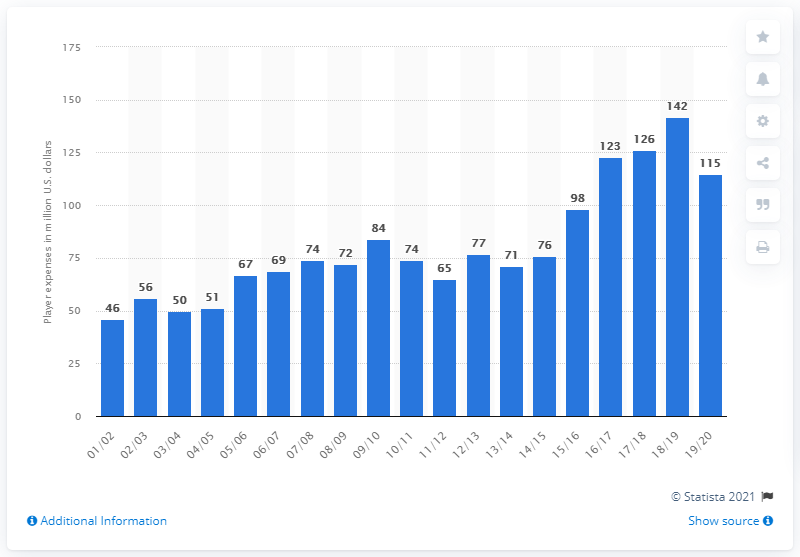Outline some significant characteristics in this image. The salary of the San Antonio Spurs in the 2019/20 season was 115.. 